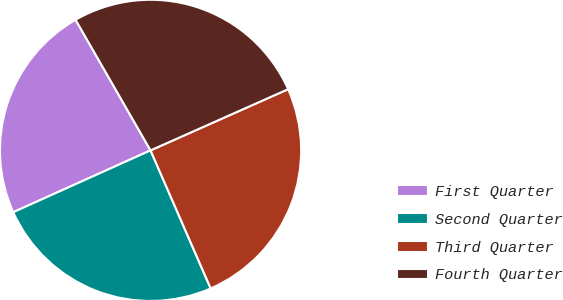<chart> <loc_0><loc_0><loc_500><loc_500><pie_chart><fcel>First Quarter<fcel>Second Quarter<fcel>Third Quarter<fcel>Fourth Quarter<nl><fcel>23.44%<fcel>24.8%<fcel>25.12%<fcel>26.63%<nl></chart> 